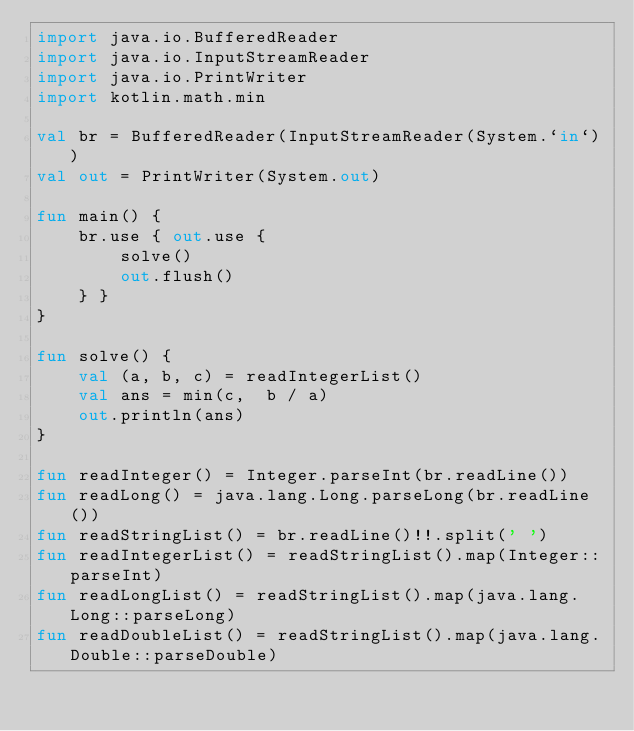<code> <loc_0><loc_0><loc_500><loc_500><_Kotlin_>import java.io.BufferedReader
import java.io.InputStreamReader
import java.io.PrintWriter
import kotlin.math.min

val br = BufferedReader(InputStreamReader(System.`in`))
val out = PrintWriter(System.out)

fun main() {
    br.use { out.use {
        solve()
        out.flush()
    } }
}

fun solve() {
    val (a, b, c) = readIntegerList()
    val ans = min(c,  b / a)
    out.println(ans)
}

fun readInteger() = Integer.parseInt(br.readLine())
fun readLong() = java.lang.Long.parseLong(br.readLine())
fun readStringList() = br.readLine()!!.split(' ')
fun readIntegerList() = readStringList().map(Integer::parseInt)
fun readLongList() = readStringList().map(java.lang.Long::parseLong)
fun readDoubleList() = readStringList().map(java.lang.Double::parseDouble)
</code> 